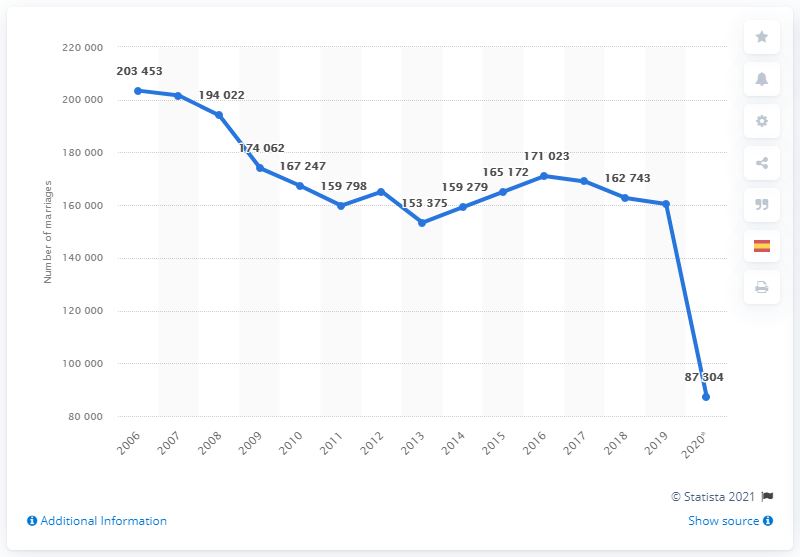Identify some key points in this picture. The average of the first two highest heterosexual marriages is 198,737.5. In 2020, there was a significant decline in heterosexual marriages. Between 2006 and 2020, a total of 201,794 heterosexual unions took place. 